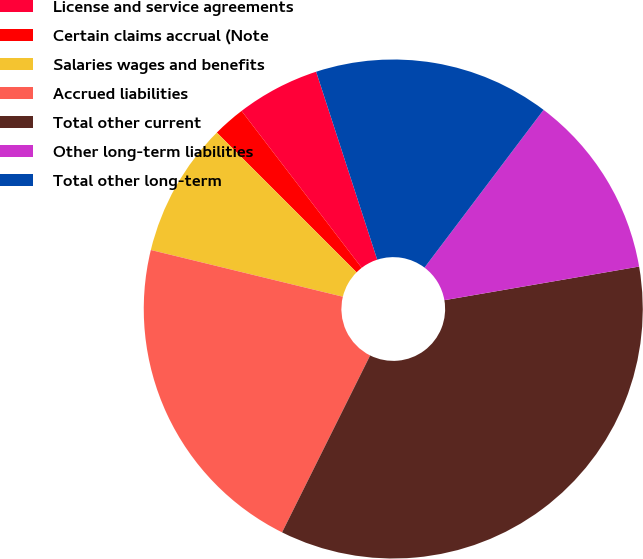Convert chart. <chart><loc_0><loc_0><loc_500><loc_500><pie_chart><fcel>License and service agreements<fcel>Certain claims accrual (Note<fcel>Salaries wages and benefits<fcel>Accrued liabilities<fcel>Total other current<fcel>Other long-term liabilities<fcel>Total other long-term<nl><fcel>5.4%<fcel>2.1%<fcel>8.7%<fcel>21.45%<fcel>35.07%<fcel>11.99%<fcel>15.29%<nl></chart> 